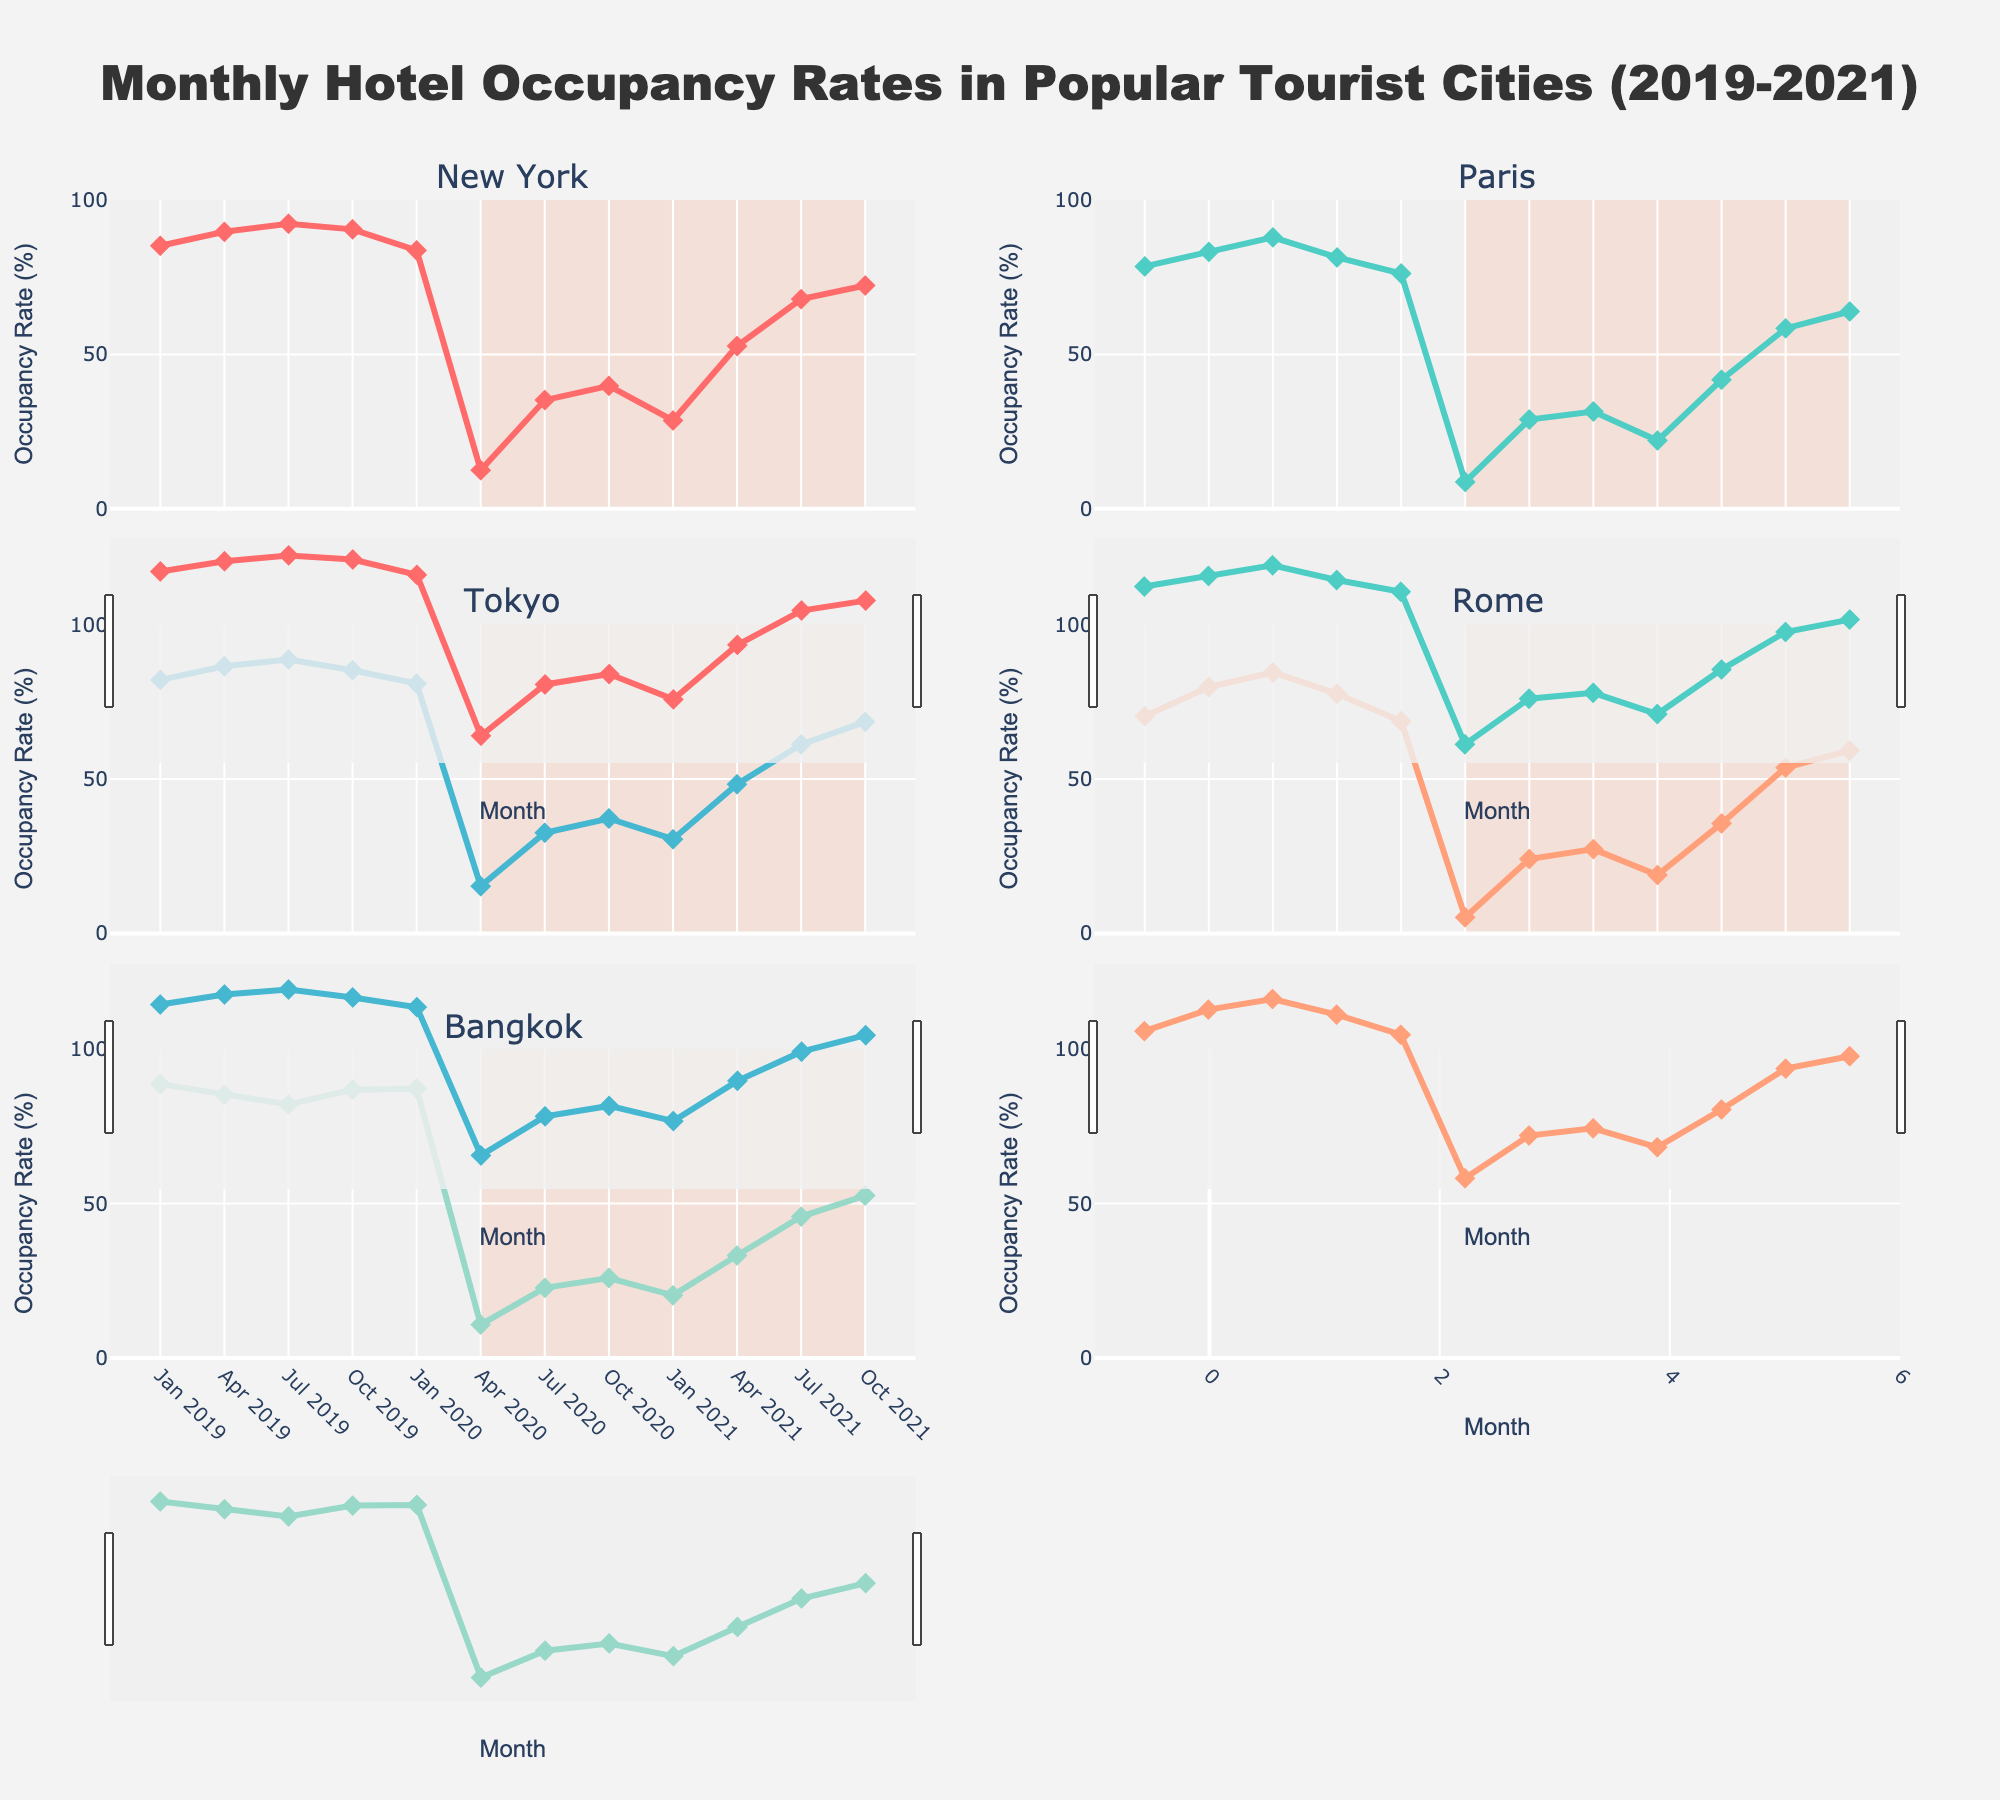What's the general trend in hotel occupancy rates from Jan 2019 to Oct 2021 across all cities? All cities show a significant drop in occupancy rates around April 2020, reaching their lowest during the pandemic, followed by a gradual recovery observed through October 2021.
Answer: Significant drop in April 2020, gradual recovery since then Which city had the highest hotel occupancy rate in Jan 2019? The subplot for Bangkok shows the highest occupancy rate, reaching 88.7% in January 2019.
Answer: Bangkok How did New York's hotel occupancy rate in April 2020 compare to its occupancy rate in July 2021? In the New York subplot, April 2020 shows a very low occupancy rate of 12.5%, while July 2021 shows a significantly higher rate of 67.9%.
Answer: 12.5% in April 2020, 67.9% in July 2021 Which city shows the most drastic drop in occupancy rate from Jan 2020 to April 2020? Comparing the drop across all cities' subplots, Rome shows the most drastic drop from 68.7% in January 2020 to 5.2% in April 2020.
Answer: Rome What is the average hotel occupancy rate for Tokyo from Jan 2019 to Oct 2021? Tokyo's rates are 82.1, 86.5, 88.7, 85.2, 80.9, 15.3, 32.6, 37.2, 30.5, 48.3, 61.2, 68.5. Summing these gives 717.4; dividing by 12 gives an average of 59.78%.
Answer: 59.78% How does the recovery rate of Paris compare to Rome from April 2020 to Oct 2021? From April 2020 to October 2021, Paris goes from 8.7% to 63.9%, increasing by 55.2%. Rome goes from 5.2% to 59.2%, increasing by 54%. Thus, Paris shows a slightly better recovery.
Answer: Paris: 55.2%, Rome: 54% Which city maintained a comparatively higher occupancy rate during the pandemic period (Apr 2020 - Oct 2021)? Bangkok's subplots indicate it maintained relatively higher occupancy rates through the pandemic period compared to other cities.
Answer: Bangkok What was the occupancy trend in April 2020 for all cities? April 2020 shows a sharp decline in occupancy rates for all cities, with New York at 12.5%, Paris at 8.7%, Tokyo at 15.3%, Rome at 5.2%, and Bangkok at 10.8%.
Answer: Sharp decline for all What's the difference in hotel occupancy rates between Tokyo and New York in Oct 2021? In October 2021, Tokyo’s occupancy rate is 68.5%, while New York’s is 72.3%. The difference is 72.3% - 68.5% = 3.8%.
Answer: 3.8% Which months in 2021 did all cities see their highest occupancy rates? All cities appear to see their highest occupancy rates around October 2021.
Answer: October 2021 